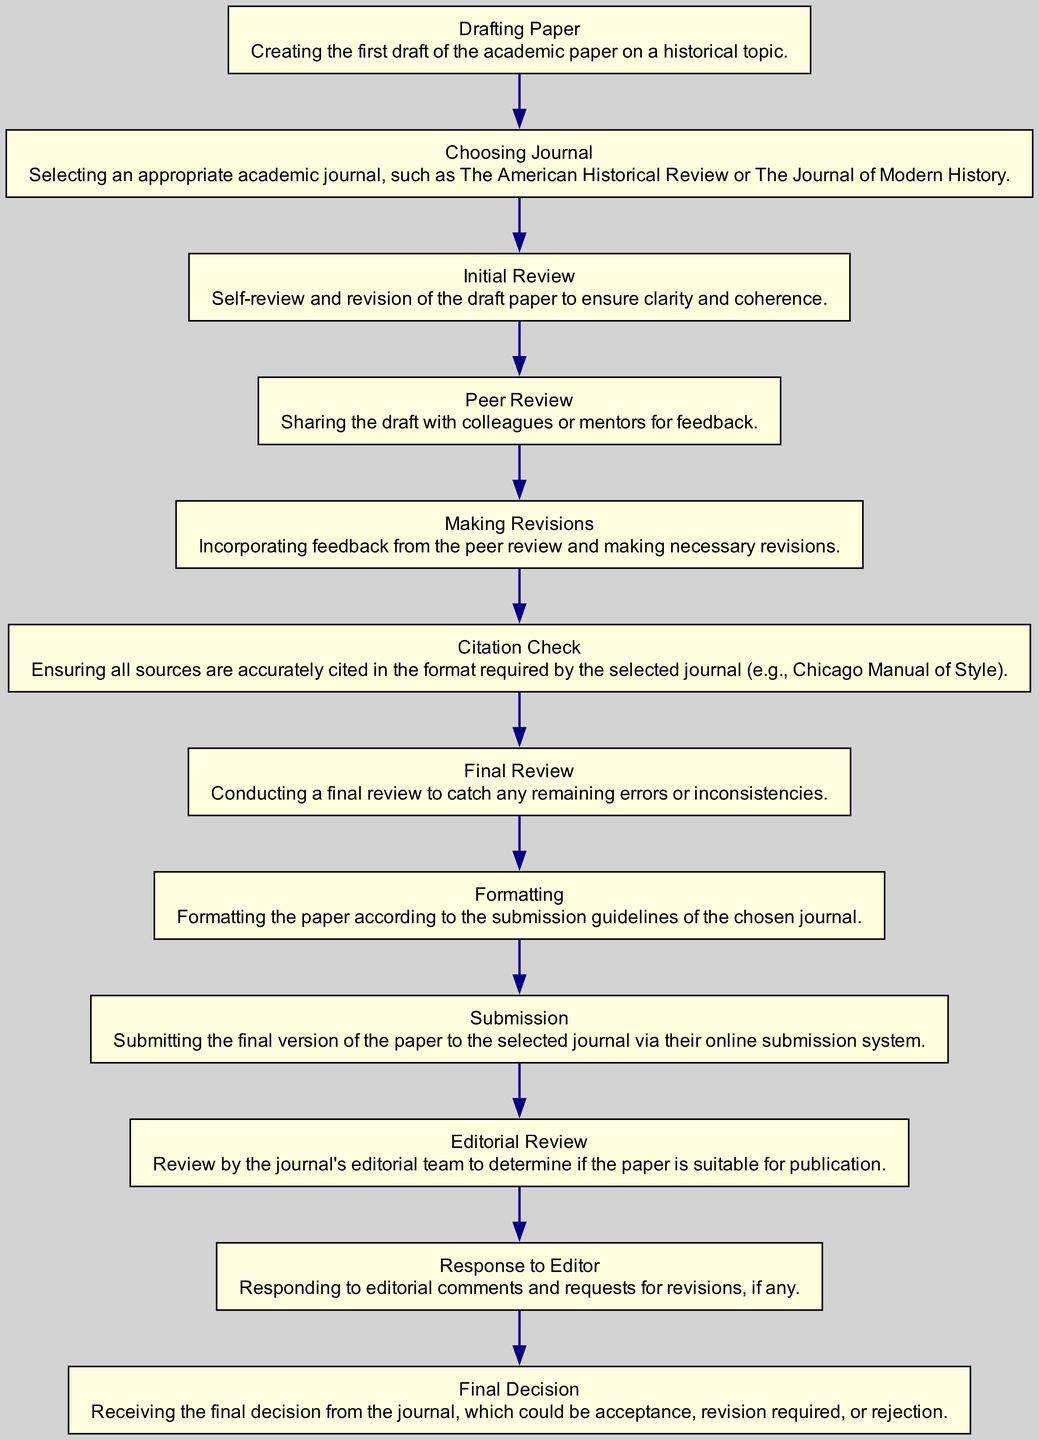What is the first step in the flowchart? The first step in the flowchart is "Drafting Paper," as indicated at the starting point of the flow series.
Answer: Drafting Paper How many total nodes are there in the diagram? Counting all the unique stages in the flowchart, there are a total of 12 nodes.
Answer: 12 What follows the "Initial Review" node? The node that follows "Initial Review" in the sequence is "Peer Review," showing the next step after reviewing the draft.
Answer: Peer Review Which stage requires incorporating feedback? The "Making Revisions" stage is specifically dedicated to incorporating feedback received from the peer review process.
Answer: Making Revisions What is the last step in the diagram? The final step in the flowchart is "Final Decision," which is the conclusion of the submission process.
Answer: Final Decision What comes immediately after "Submission"? Immediately after "Submission," the next step is "Editorial Review," where the journal's editorial team evaluates the paper.
Answer: Editorial Review What are the two steps before the "Formatting" node? The two steps before "Formatting" are "Final Review" and "Citation Check," which must be completed prior to formatting the paper.
Answer: Final Review, Citation Check How many review stages are present in the diagram? There are two review stages in the diagram: "Initial Review" and "Peer Review," followed by "Editorial Review," totaling three review phases.
Answer: 3 What is the relationship between "Peer Review" and "Revisions"? "Peer Review" leads to "Making Revisions," indicating that feedback from the peer review stage results in necessary changes (revisions).
Answer: Peer Review leads to Making Revisions 